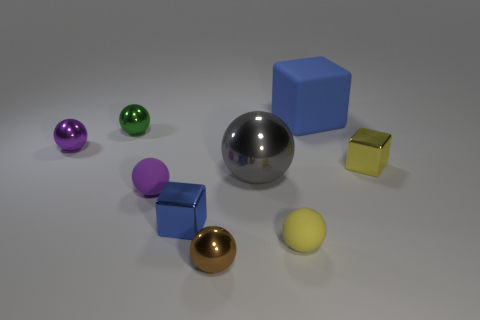There is a tiny object that is the same color as the matte cube; what is it made of?
Your answer should be compact. Metal. There is a rubber block; is it the same color as the tiny metal cube that is to the left of the yellow sphere?
Provide a short and direct response. Yes. There is a blue object that is the same size as the gray metal ball; what material is it?
Make the answer very short. Rubber. Is the shape of the tiny purple matte thing the same as the rubber object that is in front of the purple matte ball?
Offer a very short reply. Yes. There is another blue object that is the same shape as the small blue metal thing; what is it made of?
Keep it short and to the point. Rubber. There is a blue metallic cube on the right side of the purple shiny sphere; does it have the same size as the tiny yellow metal cube?
Give a very brief answer. Yes. There is a rubber thing that is to the right of the tiny brown ball and in front of the small green thing; what is its size?
Offer a very short reply. Small. What number of other things are the same size as the gray thing?
Your response must be concise. 1. There is a green thing to the left of the large gray sphere; what number of shiny balls are left of it?
Provide a succinct answer. 1. Do the block that is to the left of the large blue block and the big matte block have the same color?
Your answer should be very brief. Yes. 